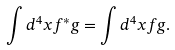<formula> <loc_0><loc_0><loc_500><loc_500>\int d ^ { 4 } x f ^ { * } g = \int d ^ { 4 } x f g .</formula> 